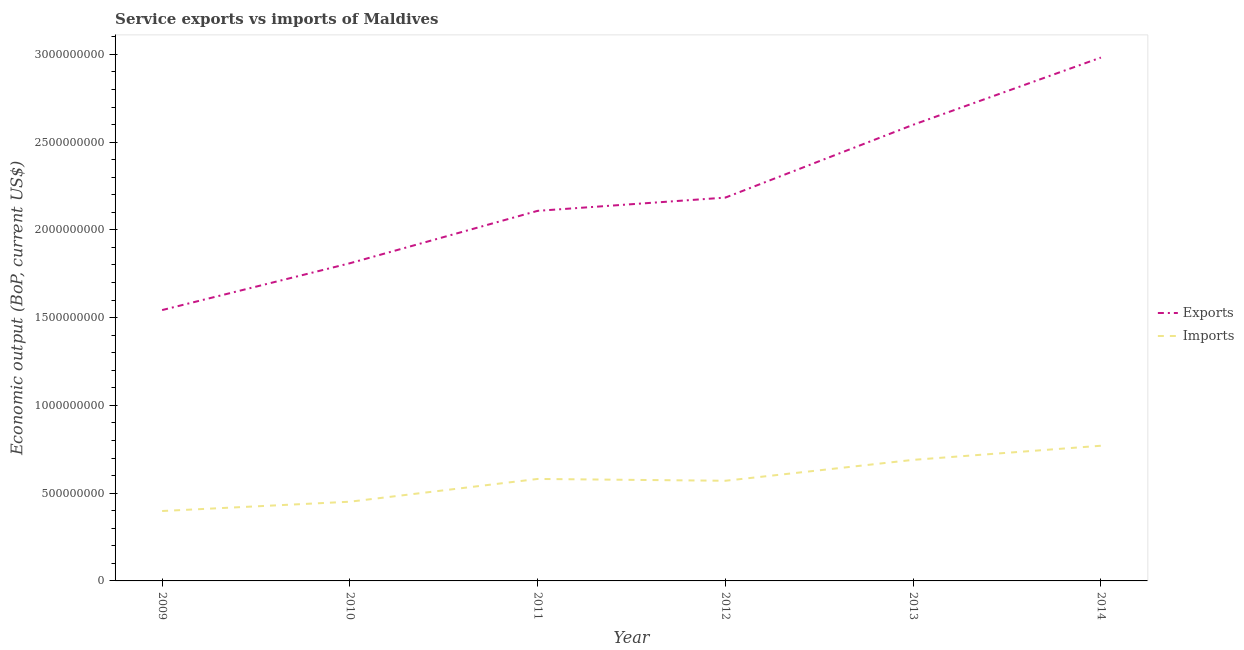How many different coloured lines are there?
Keep it short and to the point. 2. Does the line corresponding to amount of service imports intersect with the line corresponding to amount of service exports?
Keep it short and to the point. No. Is the number of lines equal to the number of legend labels?
Offer a very short reply. Yes. What is the amount of service exports in 2011?
Offer a terse response. 2.11e+09. Across all years, what is the maximum amount of service imports?
Ensure brevity in your answer.  7.70e+08. Across all years, what is the minimum amount of service exports?
Provide a succinct answer. 1.54e+09. In which year was the amount of service exports minimum?
Your answer should be compact. 2009. What is the total amount of service exports in the graph?
Your response must be concise. 1.32e+1. What is the difference between the amount of service imports in 2010 and that in 2012?
Provide a succinct answer. -1.19e+08. What is the difference between the amount of service imports in 2013 and the amount of service exports in 2011?
Your answer should be very brief. -1.42e+09. What is the average amount of service imports per year?
Provide a succinct answer. 5.77e+08. In the year 2010, what is the difference between the amount of service exports and amount of service imports?
Give a very brief answer. 1.36e+09. In how many years, is the amount of service imports greater than 1500000000 US$?
Your answer should be very brief. 0. What is the ratio of the amount of service exports in 2009 to that in 2013?
Provide a short and direct response. 0.59. Is the amount of service exports in 2010 less than that in 2014?
Make the answer very short. Yes. What is the difference between the highest and the second highest amount of service exports?
Ensure brevity in your answer.  3.83e+08. What is the difference between the highest and the lowest amount of service imports?
Make the answer very short. 3.72e+08. In how many years, is the amount of service imports greater than the average amount of service imports taken over all years?
Ensure brevity in your answer.  3. Does the amount of service exports monotonically increase over the years?
Make the answer very short. Yes. Is the amount of service imports strictly greater than the amount of service exports over the years?
Offer a very short reply. No. How many years are there in the graph?
Provide a short and direct response. 6. What is the difference between two consecutive major ticks on the Y-axis?
Give a very brief answer. 5.00e+08. Does the graph contain grids?
Offer a very short reply. No. Where does the legend appear in the graph?
Provide a succinct answer. Center right. How many legend labels are there?
Offer a terse response. 2. How are the legend labels stacked?
Your answer should be compact. Vertical. What is the title of the graph?
Your answer should be very brief. Service exports vs imports of Maldives. Does "RDB concessional" appear as one of the legend labels in the graph?
Ensure brevity in your answer.  No. What is the label or title of the Y-axis?
Give a very brief answer. Economic output (BoP, current US$). What is the Economic output (BoP, current US$) in Exports in 2009?
Ensure brevity in your answer.  1.54e+09. What is the Economic output (BoP, current US$) in Imports in 2009?
Make the answer very short. 3.98e+08. What is the Economic output (BoP, current US$) of Exports in 2010?
Keep it short and to the point. 1.81e+09. What is the Economic output (BoP, current US$) in Imports in 2010?
Make the answer very short. 4.51e+08. What is the Economic output (BoP, current US$) in Exports in 2011?
Your answer should be compact. 2.11e+09. What is the Economic output (BoP, current US$) in Imports in 2011?
Provide a succinct answer. 5.81e+08. What is the Economic output (BoP, current US$) in Exports in 2012?
Provide a succinct answer. 2.18e+09. What is the Economic output (BoP, current US$) in Imports in 2012?
Provide a short and direct response. 5.71e+08. What is the Economic output (BoP, current US$) in Exports in 2013?
Give a very brief answer. 2.60e+09. What is the Economic output (BoP, current US$) in Imports in 2013?
Offer a terse response. 6.90e+08. What is the Economic output (BoP, current US$) in Exports in 2014?
Keep it short and to the point. 2.98e+09. What is the Economic output (BoP, current US$) in Imports in 2014?
Give a very brief answer. 7.70e+08. Across all years, what is the maximum Economic output (BoP, current US$) of Exports?
Your response must be concise. 2.98e+09. Across all years, what is the maximum Economic output (BoP, current US$) in Imports?
Ensure brevity in your answer.  7.70e+08. Across all years, what is the minimum Economic output (BoP, current US$) in Exports?
Ensure brevity in your answer.  1.54e+09. Across all years, what is the minimum Economic output (BoP, current US$) in Imports?
Provide a succinct answer. 3.98e+08. What is the total Economic output (BoP, current US$) of Exports in the graph?
Your answer should be very brief. 1.32e+1. What is the total Economic output (BoP, current US$) of Imports in the graph?
Provide a succinct answer. 3.46e+09. What is the difference between the Economic output (BoP, current US$) in Exports in 2009 and that in 2010?
Provide a short and direct response. -2.67e+08. What is the difference between the Economic output (BoP, current US$) in Imports in 2009 and that in 2010?
Offer a very short reply. -5.30e+07. What is the difference between the Economic output (BoP, current US$) in Exports in 2009 and that in 2011?
Provide a short and direct response. -5.65e+08. What is the difference between the Economic output (BoP, current US$) in Imports in 2009 and that in 2011?
Give a very brief answer. -1.83e+08. What is the difference between the Economic output (BoP, current US$) in Exports in 2009 and that in 2012?
Give a very brief answer. -6.41e+08. What is the difference between the Economic output (BoP, current US$) in Imports in 2009 and that in 2012?
Keep it short and to the point. -1.72e+08. What is the difference between the Economic output (BoP, current US$) of Exports in 2009 and that in 2013?
Provide a short and direct response. -1.06e+09. What is the difference between the Economic output (BoP, current US$) in Imports in 2009 and that in 2013?
Your response must be concise. -2.91e+08. What is the difference between the Economic output (BoP, current US$) of Exports in 2009 and that in 2014?
Your response must be concise. -1.44e+09. What is the difference between the Economic output (BoP, current US$) of Imports in 2009 and that in 2014?
Ensure brevity in your answer.  -3.72e+08. What is the difference between the Economic output (BoP, current US$) of Exports in 2010 and that in 2011?
Keep it short and to the point. -2.99e+08. What is the difference between the Economic output (BoP, current US$) of Imports in 2010 and that in 2011?
Provide a short and direct response. -1.30e+08. What is the difference between the Economic output (BoP, current US$) of Exports in 2010 and that in 2012?
Ensure brevity in your answer.  -3.74e+08. What is the difference between the Economic output (BoP, current US$) in Imports in 2010 and that in 2012?
Provide a succinct answer. -1.19e+08. What is the difference between the Economic output (BoP, current US$) of Exports in 2010 and that in 2013?
Give a very brief answer. -7.89e+08. What is the difference between the Economic output (BoP, current US$) in Imports in 2010 and that in 2013?
Provide a short and direct response. -2.38e+08. What is the difference between the Economic output (BoP, current US$) in Exports in 2010 and that in 2014?
Provide a succinct answer. -1.17e+09. What is the difference between the Economic output (BoP, current US$) of Imports in 2010 and that in 2014?
Keep it short and to the point. -3.19e+08. What is the difference between the Economic output (BoP, current US$) in Exports in 2011 and that in 2012?
Ensure brevity in your answer.  -7.55e+07. What is the difference between the Economic output (BoP, current US$) of Imports in 2011 and that in 2012?
Offer a terse response. 1.04e+07. What is the difference between the Economic output (BoP, current US$) of Exports in 2011 and that in 2013?
Give a very brief answer. -4.90e+08. What is the difference between the Economic output (BoP, current US$) of Imports in 2011 and that in 2013?
Your answer should be very brief. -1.09e+08. What is the difference between the Economic output (BoP, current US$) in Exports in 2011 and that in 2014?
Provide a succinct answer. -8.73e+08. What is the difference between the Economic output (BoP, current US$) in Imports in 2011 and that in 2014?
Ensure brevity in your answer.  -1.89e+08. What is the difference between the Economic output (BoP, current US$) of Exports in 2012 and that in 2013?
Make the answer very short. -4.15e+08. What is the difference between the Economic output (BoP, current US$) in Imports in 2012 and that in 2013?
Ensure brevity in your answer.  -1.19e+08. What is the difference between the Economic output (BoP, current US$) of Exports in 2012 and that in 2014?
Give a very brief answer. -7.98e+08. What is the difference between the Economic output (BoP, current US$) in Imports in 2012 and that in 2014?
Keep it short and to the point. -2.00e+08. What is the difference between the Economic output (BoP, current US$) of Exports in 2013 and that in 2014?
Keep it short and to the point. -3.83e+08. What is the difference between the Economic output (BoP, current US$) of Imports in 2013 and that in 2014?
Provide a succinct answer. -8.04e+07. What is the difference between the Economic output (BoP, current US$) in Exports in 2009 and the Economic output (BoP, current US$) in Imports in 2010?
Give a very brief answer. 1.09e+09. What is the difference between the Economic output (BoP, current US$) of Exports in 2009 and the Economic output (BoP, current US$) of Imports in 2011?
Offer a very short reply. 9.62e+08. What is the difference between the Economic output (BoP, current US$) of Exports in 2009 and the Economic output (BoP, current US$) of Imports in 2012?
Give a very brief answer. 9.73e+08. What is the difference between the Economic output (BoP, current US$) of Exports in 2009 and the Economic output (BoP, current US$) of Imports in 2013?
Give a very brief answer. 8.53e+08. What is the difference between the Economic output (BoP, current US$) of Exports in 2009 and the Economic output (BoP, current US$) of Imports in 2014?
Ensure brevity in your answer.  7.73e+08. What is the difference between the Economic output (BoP, current US$) of Exports in 2010 and the Economic output (BoP, current US$) of Imports in 2011?
Keep it short and to the point. 1.23e+09. What is the difference between the Economic output (BoP, current US$) in Exports in 2010 and the Economic output (BoP, current US$) in Imports in 2012?
Offer a terse response. 1.24e+09. What is the difference between the Economic output (BoP, current US$) of Exports in 2010 and the Economic output (BoP, current US$) of Imports in 2013?
Offer a very short reply. 1.12e+09. What is the difference between the Economic output (BoP, current US$) in Exports in 2010 and the Economic output (BoP, current US$) in Imports in 2014?
Provide a succinct answer. 1.04e+09. What is the difference between the Economic output (BoP, current US$) in Exports in 2011 and the Economic output (BoP, current US$) in Imports in 2012?
Ensure brevity in your answer.  1.54e+09. What is the difference between the Economic output (BoP, current US$) of Exports in 2011 and the Economic output (BoP, current US$) of Imports in 2013?
Keep it short and to the point. 1.42e+09. What is the difference between the Economic output (BoP, current US$) of Exports in 2011 and the Economic output (BoP, current US$) of Imports in 2014?
Offer a terse response. 1.34e+09. What is the difference between the Economic output (BoP, current US$) of Exports in 2012 and the Economic output (BoP, current US$) of Imports in 2013?
Ensure brevity in your answer.  1.49e+09. What is the difference between the Economic output (BoP, current US$) in Exports in 2012 and the Economic output (BoP, current US$) in Imports in 2014?
Offer a terse response. 1.41e+09. What is the difference between the Economic output (BoP, current US$) of Exports in 2013 and the Economic output (BoP, current US$) of Imports in 2014?
Provide a succinct answer. 1.83e+09. What is the average Economic output (BoP, current US$) in Exports per year?
Offer a very short reply. 2.20e+09. What is the average Economic output (BoP, current US$) of Imports per year?
Your answer should be compact. 5.77e+08. In the year 2009, what is the difference between the Economic output (BoP, current US$) of Exports and Economic output (BoP, current US$) of Imports?
Your response must be concise. 1.14e+09. In the year 2010, what is the difference between the Economic output (BoP, current US$) in Exports and Economic output (BoP, current US$) in Imports?
Offer a very short reply. 1.36e+09. In the year 2011, what is the difference between the Economic output (BoP, current US$) of Exports and Economic output (BoP, current US$) of Imports?
Your response must be concise. 1.53e+09. In the year 2012, what is the difference between the Economic output (BoP, current US$) of Exports and Economic output (BoP, current US$) of Imports?
Your response must be concise. 1.61e+09. In the year 2013, what is the difference between the Economic output (BoP, current US$) in Exports and Economic output (BoP, current US$) in Imports?
Give a very brief answer. 1.91e+09. In the year 2014, what is the difference between the Economic output (BoP, current US$) in Exports and Economic output (BoP, current US$) in Imports?
Provide a short and direct response. 2.21e+09. What is the ratio of the Economic output (BoP, current US$) in Exports in 2009 to that in 2010?
Provide a succinct answer. 0.85. What is the ratio of the Economic output (BoP, current US$) of Imports in 2009 to that in 2010?
Your answer should be compact. 0.88. What is the ratio of the Economic output (BoP, current US$) in Exports in 2009 to that in 2011?
Provide a short and direct response. 0.73. What is the ratio of the Economic output (BoP, current US$) of Imports in 2009 to that in 2011?
Provide a succinct answer. 0.69. What is the ratio of the Economic output (BoP, current US$) in Exports in 2009 to that in 2012?
Provide a succinct answer. 0.71. What is the ratio of the Economic output (BoP, current US$) of Imports in 2009 to that in 2012?
Offer a terse response. 0.7. What is the ratio of the Economic output (BoP, current US$) in Exports in 2009 to that in 2013?
Ensure brevity in your answer.  0.59. What is the ratio of the Economic output (BoP, current US$) in Imports in 2009 to that in 2013?
Keep it short and to the point. 0.58. What is the ratio of the Economic output (BoP, current US$) in Exports in 2009 to that in 2014?
Keep it short and to the point. 0.52. What is the ratio of the Economic output (BoP, current US$) of Imports in 2009 to that in 2014?
Your answer should be very brief. 0.52. What is the ratio of the Economic output (BoP, current US$) in Exports in 2010 to that in 2011?
Keep it short and to the point. 0.86. What is the ratio of the Economic output (BoP, current US$) of Imports in 2010 to that in 2011?
Your answer should be compact. 0.78. What is the ratio of the Economic output (BoP, current US$) in Exports in 2010 to that in 2012?
Keep it short and to the point. 0.83. What is the ratio of the Economic output (BoP, current US$) in Imports in 2010 to that in 2012?
Give a very brief answer. 0.79. What is the ratio of the Economic output (BoP, current US$) in Exports in 2010 to that in 2013?
Offer a terse response. 0.7. What is the ratio of the Economic output (BoP, current US$) in Imports in 2010 to that in 2013?
Provide a short and direct response. 0.65. What is the ratio of the Economic output (BoP, current US$) of Exports in 2010 to that in 2014?
Your answer should be compact. 0.61. What is the ratio of the Economic output (BoP, current US$) of Imports in 2010 to that in 2014?
Provide a short and direct response. 0.59. What is the ratio of the Economic output (BoP, current US$) of Exports in 2011 to that in 2012?
Provide a short and direct response. 0.97. What is the ratio of the Economic output (BoP, current US$) of Imports in 2011 to that in 2012?
Offer a very short reply. 1.02. What is the ratio of the Economic output (BoP, current US$) in Exports in 2011 to that in 2013?
Offer a very short reply. 0.81. What is the ratio of the Economic output (BoP, current US$) of Imports in 2011 to that in 2013?
Give a very brief answer. 0.84. What is the ratio of the Economic output (BoP, current US$) in Exports in 2011 to that in 2014?
Offer a terse response. 0.71. What is the ratio of the Economic output (BoP, current US$) in Imports in 2011 to that in 2014?
Make the answer very short. 0.75. What is the ratio of the Economic output (BoP, current US$) in Exports in 2012 to that in 2013?
Ensure brevity in your answer.  0.84. What is the ratio of the Economic output (BoP, current US$) in Imports in 2012 to that in 2013?
Ensure brevity in your answer.  0.83. What is the ratio of the Economic output (BoP, current US$) in Exports in 2012 to that in 2014?
Your answer should be compact. 0.73. What is the ratio of the Economic output (BoP, current US$) in Imports in 2012 to that in 2014?
Make the answer very short. 0.74. What is the ratio of the Economic output (BoP, current US$) in Exports in 2013 to that in 2014?
Keep it short and to the point. 0.87. What is the ratio of the Economic output (BoP, current US$) in Imports in 2013 to that in 2014?
Give a very brief answer. 0.9. What is the difference between the highest and the second highest Economic output (BoP, current US$) in Exports?
Offer a terse response. 3.83e+08. What is the difference between the highest and the second highest Economic output (BoP, current US$) of Imports?
Make the answer very short. 8.04e+07. What is the difference between the highest and the lowest Economic output (BoP, current US$) of Exports?
Make the answer very short. 1.44e+09. What is the difference between the highest and the lowest Economic output (BoP, current US$) in Imports?
Provide a short and direct response. 3.72e+08. 